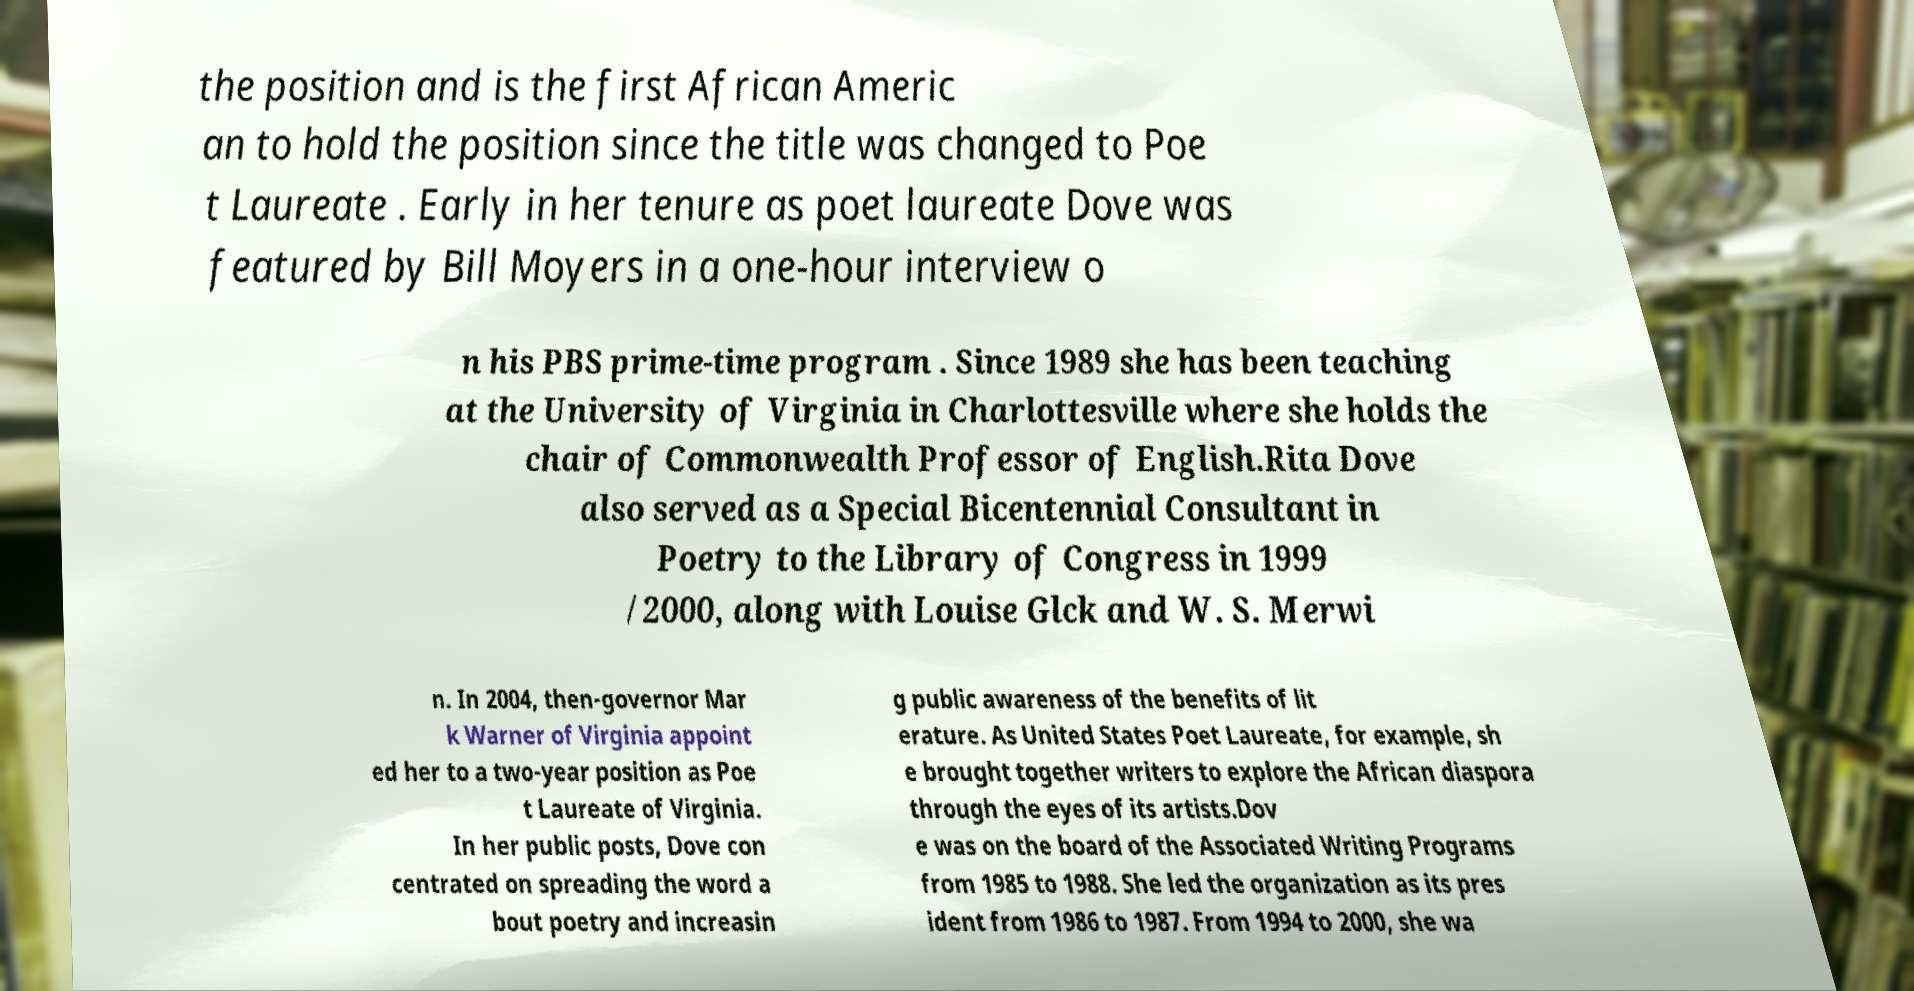What messages or text are displayed in this image? I need them in a readable, typed format. the position and is the first African Americ an to hold the position since the title was changed to Poe t Laureate . Early in her tenure as poet laureate Dove was featured by Bill Moyers in a one-hour interview o n his PBS prime-time program . Since 1989 she has been teaching at the University of Virginia in Charlottesville where she holds the chair of Commonwealth Professor of English.Rita Dove also served as a Special Bicentennial Consultant in Poetry to the Library of Congress in 1999 /2000, along with Louise Glck and W. S. Merwi n. In 2004, then-governor Mar k Warner of Virginia appoint ed her to a two-year position as Poe t Laureate of Virginia. In her public posts, Dove con centrated on spreading the word a bout poetry and increasin g public awareness of the benefits of lit erature. As United States Poet Laureate, for example, sh e brought together writers to explore the African diaspora through the eyes of its artists.Dov e was on the board of the Associated Writing Programs from 1985 to 1988. She led the organization as its pres ident from 1986 to 1987. From 1994 to 2000, she wa 